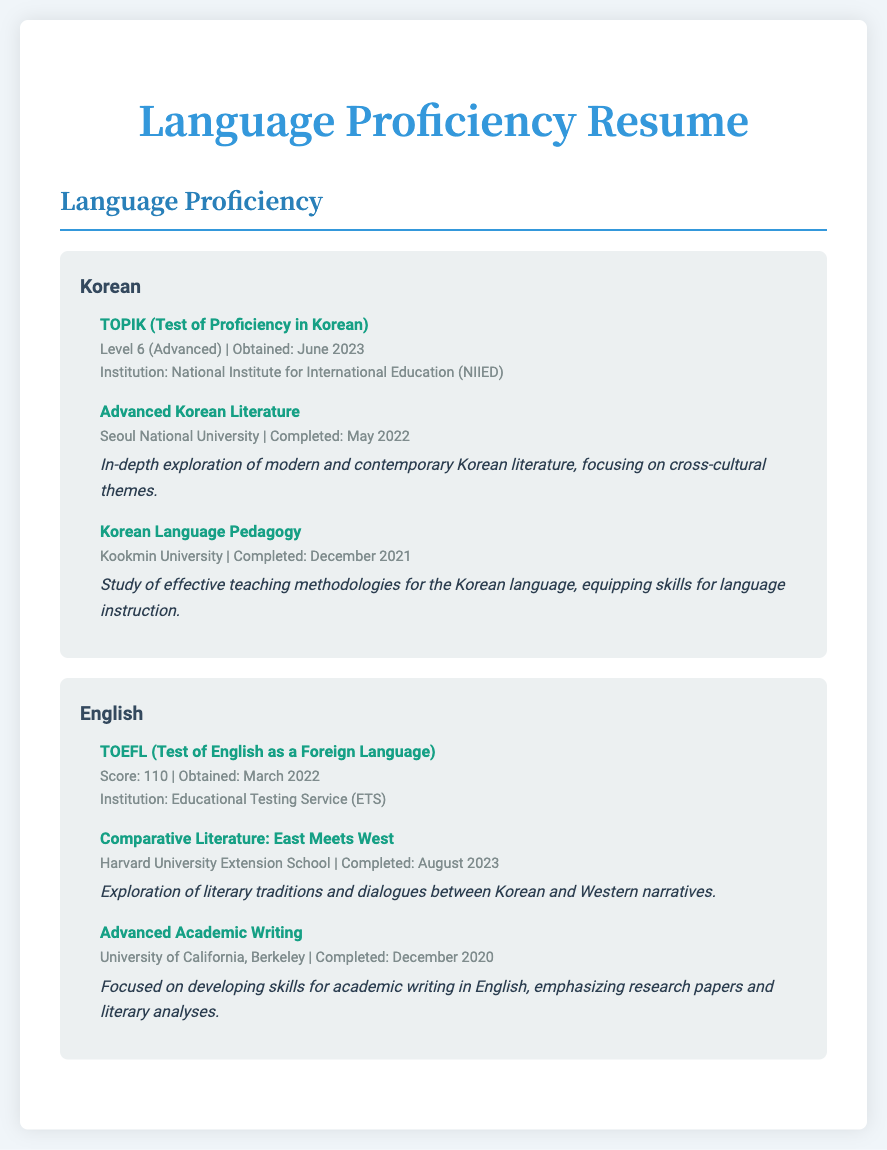What is the highest level achieved in TOPIK? The TOPIK level achieved is 6, which is classified as Advanced.
Answer: Level 6 When was the TOEFL exam obtained? The TOEFL exam was obtained in March 2022.
Answer: March 2022 Which institution awarded a certification for Korean proficiency? The certification for Korean proficiency was awarded by the National Institute for International Education (NIIED).
Answer: National Institute for International Education (NIIED) What was the score obtained in the TOEFL? The score obtained in the TOEFL was 110.
Answer: 110 What course focuses on modern and contemporary Korean literature? The course that focuses on modern and contemporary Korean literature is titled "Advanced Korean Literature".
Answer: Advanced Korean Literature Which university offered the course "Comparative Literature: East Meets West"? The course "Comparative Literature: East Meets West" was offered by Harvard University Extension School.
Answer: Harvard University Extension School How many courses are listed under Korean language coursework? There are two courses listed under Korean language coursework.
Answer: Two What is the primary focus of the course "Korean Language Pedagogy"? The primary focus of the course "Korean Language Pedagogy" is effective teaching methodologies for the Korean language.
Answer: Effective teaching methodologies When was the course "Advanced Academic Writing" completed? The course "Advanced Academic Writing" was completed in December 2020.
Answer: December 2020 